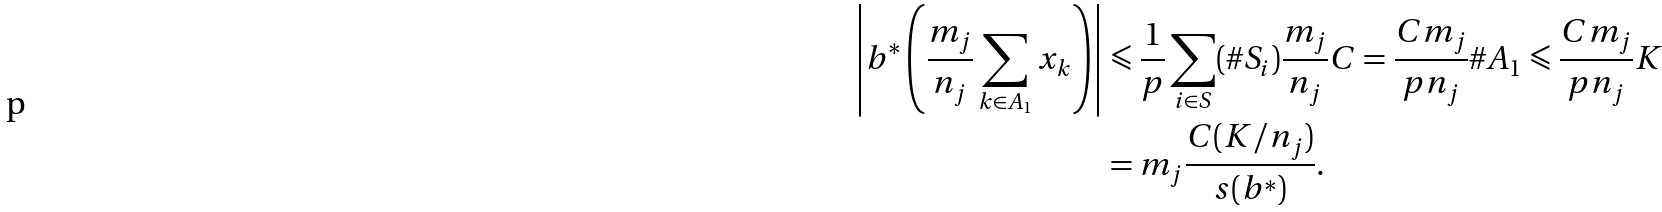Convert formula to latex. <formula><loc_0><loc_0><loc_500><loc_500>\left | b ^ { * } \left ( \frac { m _ { j } } { n _ { j } } \sum _ { k \in A _ { 1 } } x _ { k } \right ) \right | & \leqslant \frac { 1 } { p } \sum _ { i \in S } ( \# S _ { i } ) \frac { m _ { j } } { n _ { j } } C = \frac { C m _ { j } } { p n _ { j } } \# A _ { 1 } \leqslant \frac { C m _ { j } } { p n _ { j } } K \\ & = m _ { j } \frac { C ( K / n _ { j } ) } { s ( b ^ { * } ) } .</formula> 